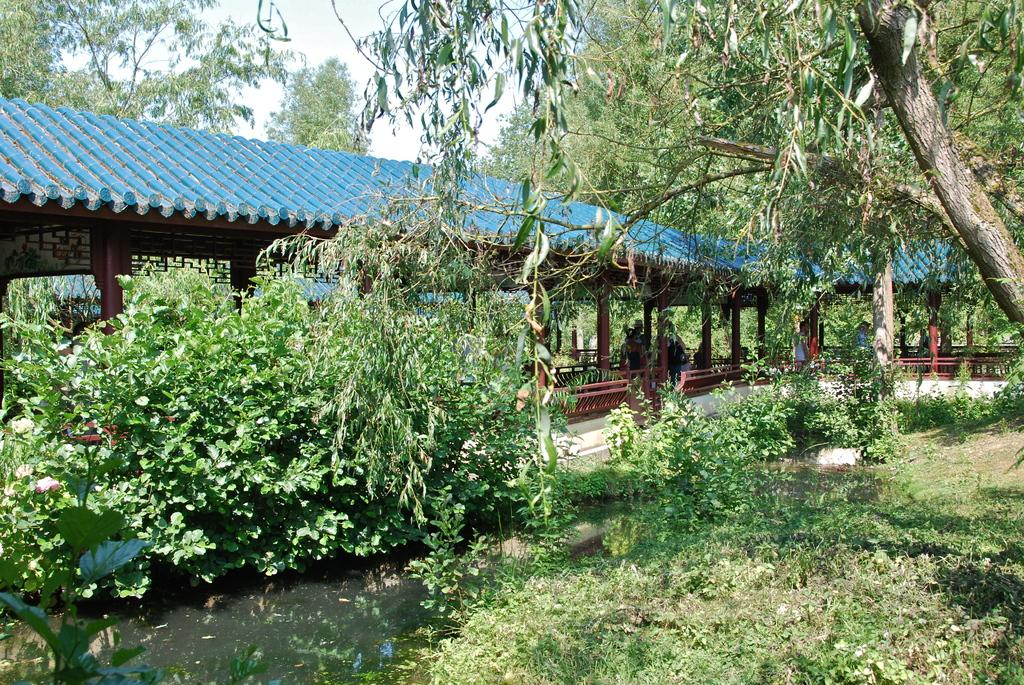What type of structure is visible in the image? There is a wooden shed roof construction in the image. What natural elements can be seen in the image? Water, grass, plants, trees, and the sky are visible in the image. What type of vegetation is present in the image? Plants and trees are present in the image. Are there any people visible in the image? Yes, there are people wearing clothes in the image. What type of hill can be seen in the image? There is no hill visible in the image. What kind of work are the people doing in the image? The provided facts do not mention any specific work being done by the people in the image. 